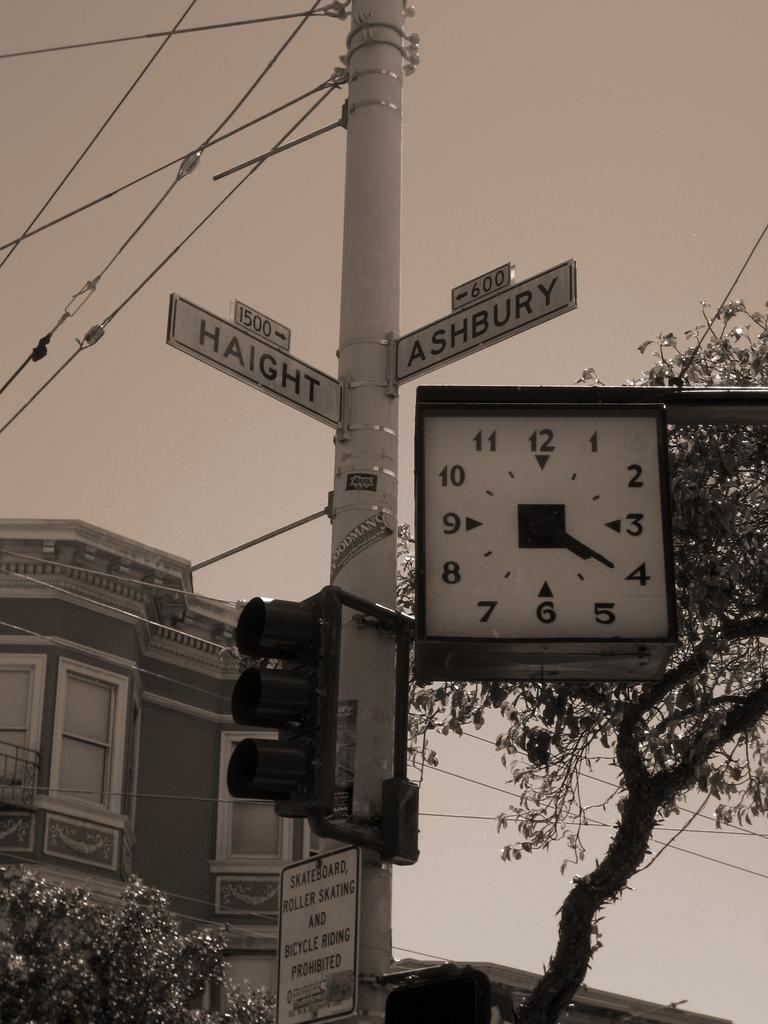What object in the image is used for measuring time? There is a clock in the image that is used for measuring time. What vertical structure can be seen in the image? There is a pole in the image. What device is used to control traffic in the image? There is a traffic signal in the image. What type of vegetation is present in the image? There are trees in the image. What type of man-made structure is visible in the image? There is a building in the image. What architectural feature can be seen in the image? There are windows in the image. What part of the natural environment is visible in the image? The sky is visible in the image. Reasoning: Let' Let's think step by step in order to produce the conversation. We start by identifying the main objects and structures in the image based on the provided facts. We then formulate questions that focus on the characteristics and functions of these objects and structures, ensuring that each question can be answered definitively with the information given. We avoid yes/no questions and ensure that the language is simple and clear. Absurd Question/Answer: Can you tell me how many fuel stations are visible in the image? There are no fuel stations present in the image. What type of playground equipment can be seen near the trees in the image? There is no playground equipment present in the image. What type of fuel is being used by the vehicles near the playground equipment in the image? There are no vehicles or playground equipment present in the image, so it is not possible to determine the type of fuel being used. 